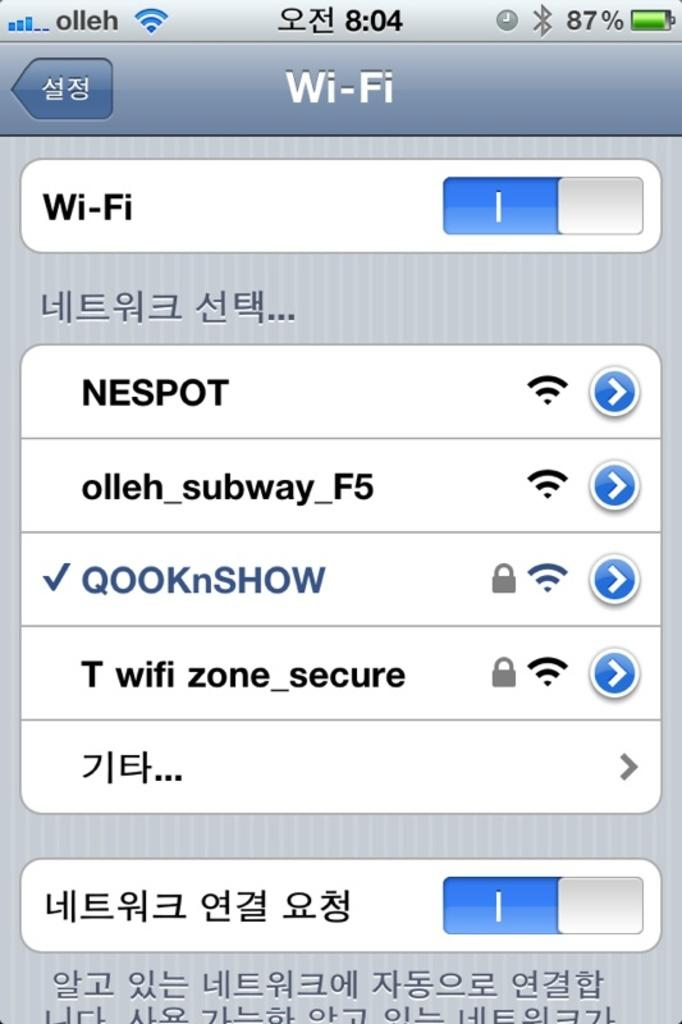Provide a one-sentence caption for the provided image. A phone display shows that it is connected to wi-fi. 